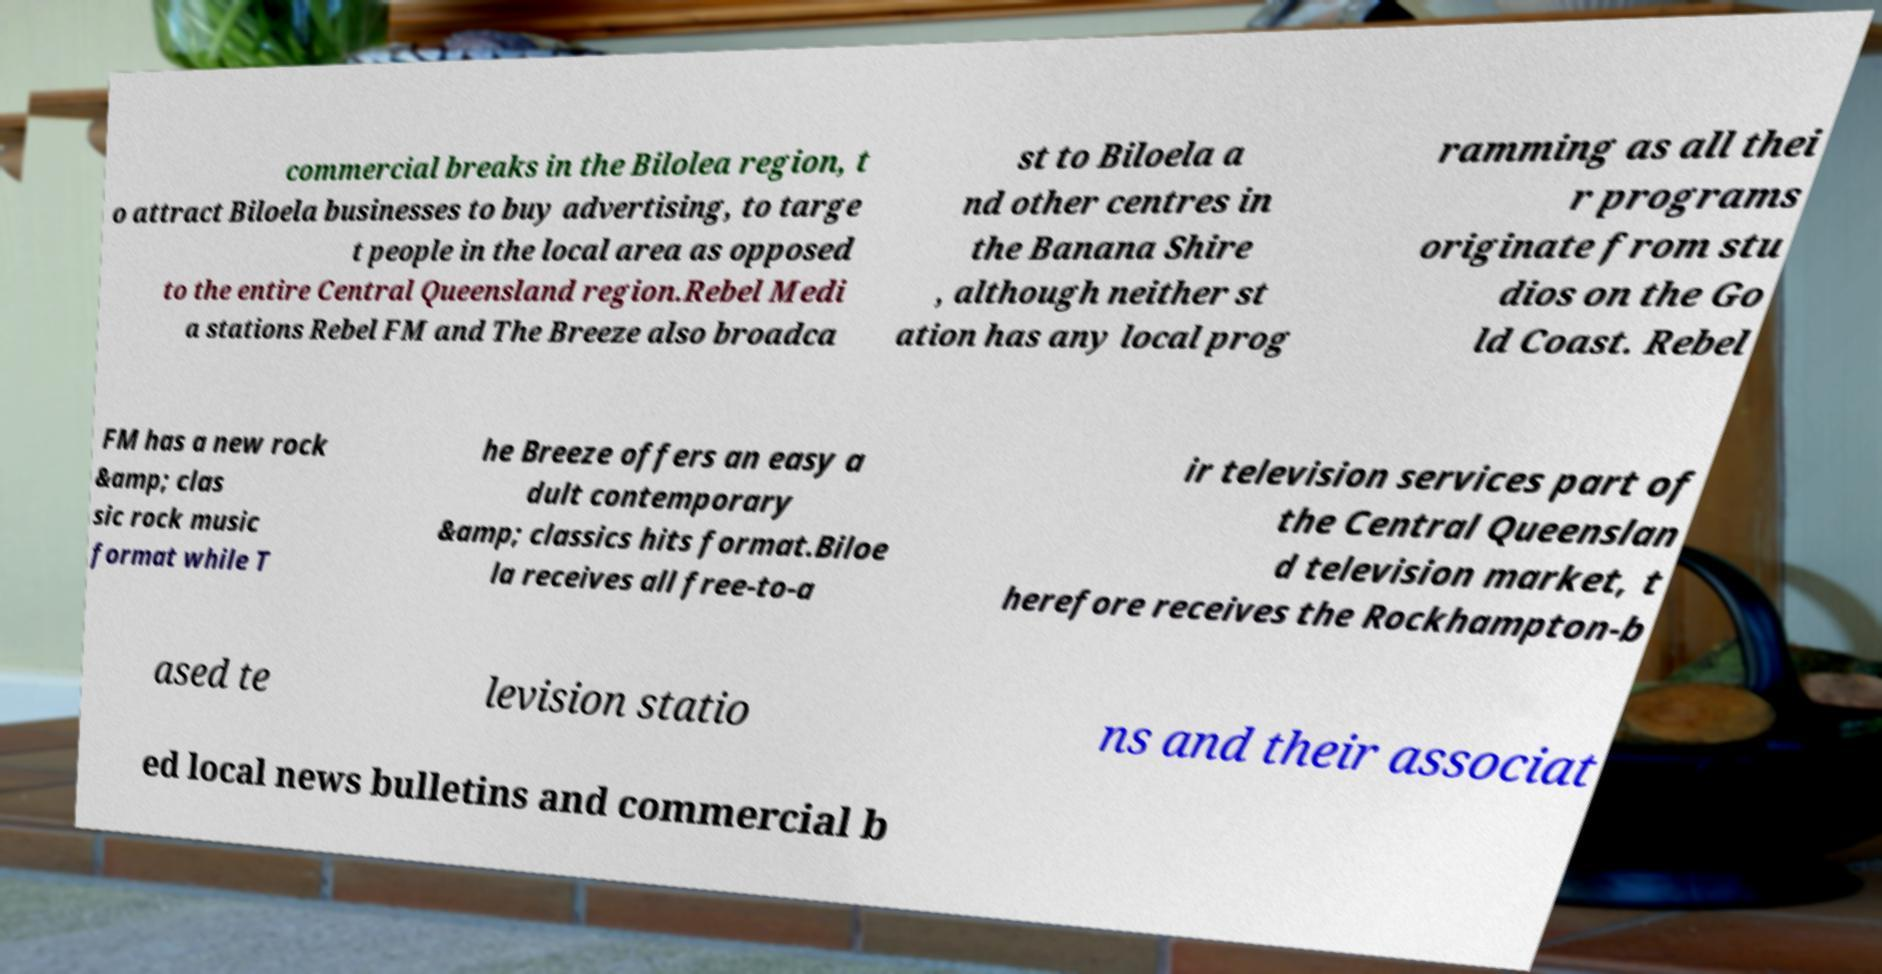Please identify and transcribe the text found in this image. commercial breaks in the Bilolea region, t o attract Biloela businesses to buy advertising, to targe t people in the local area as opposed to the entire Central Queensland region.Rebel Medi a stations Rebel FM and The Breeze also broadca st to Biloela a nd other centres in the Banana Shire , although neither st ation has any local prog ramming as all thei r programs originate from stu dios on the Go ld Coast. Rebel FM has a new rock &amp; clas sic rock music format while T he Breeze offers an easy a dult contemporary &amp; classics hits format.Biloe la receives all free-to-a ir television services part of the Central Queenslan d television market, t herefore receives the Rockhampton-b ased te levision statio ns and their associat ed local news bulletins and commercial b 